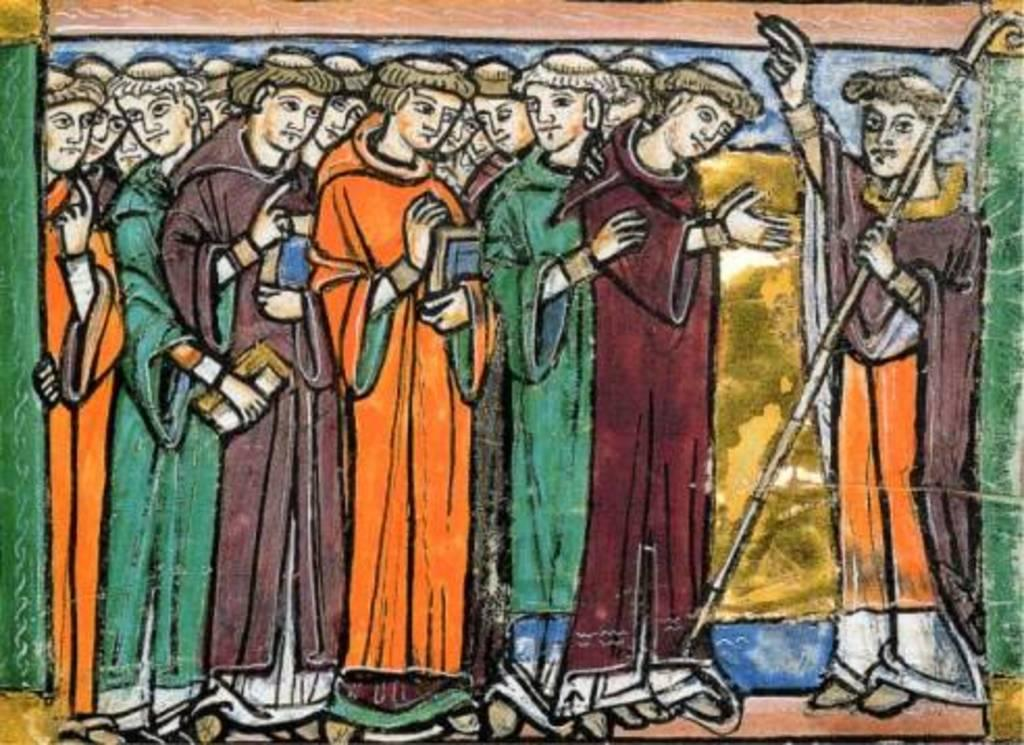What is the main subject of the image? There is a painting in the image. What is depicted in the painting? The painting depicts people. How many fish can be seen swimming in the painting? There are no fish present in the painting; it depicts people. What type of footwear are the people wearing in the painting? The provided facts do not mention any footwear worn by the people in the painting. 